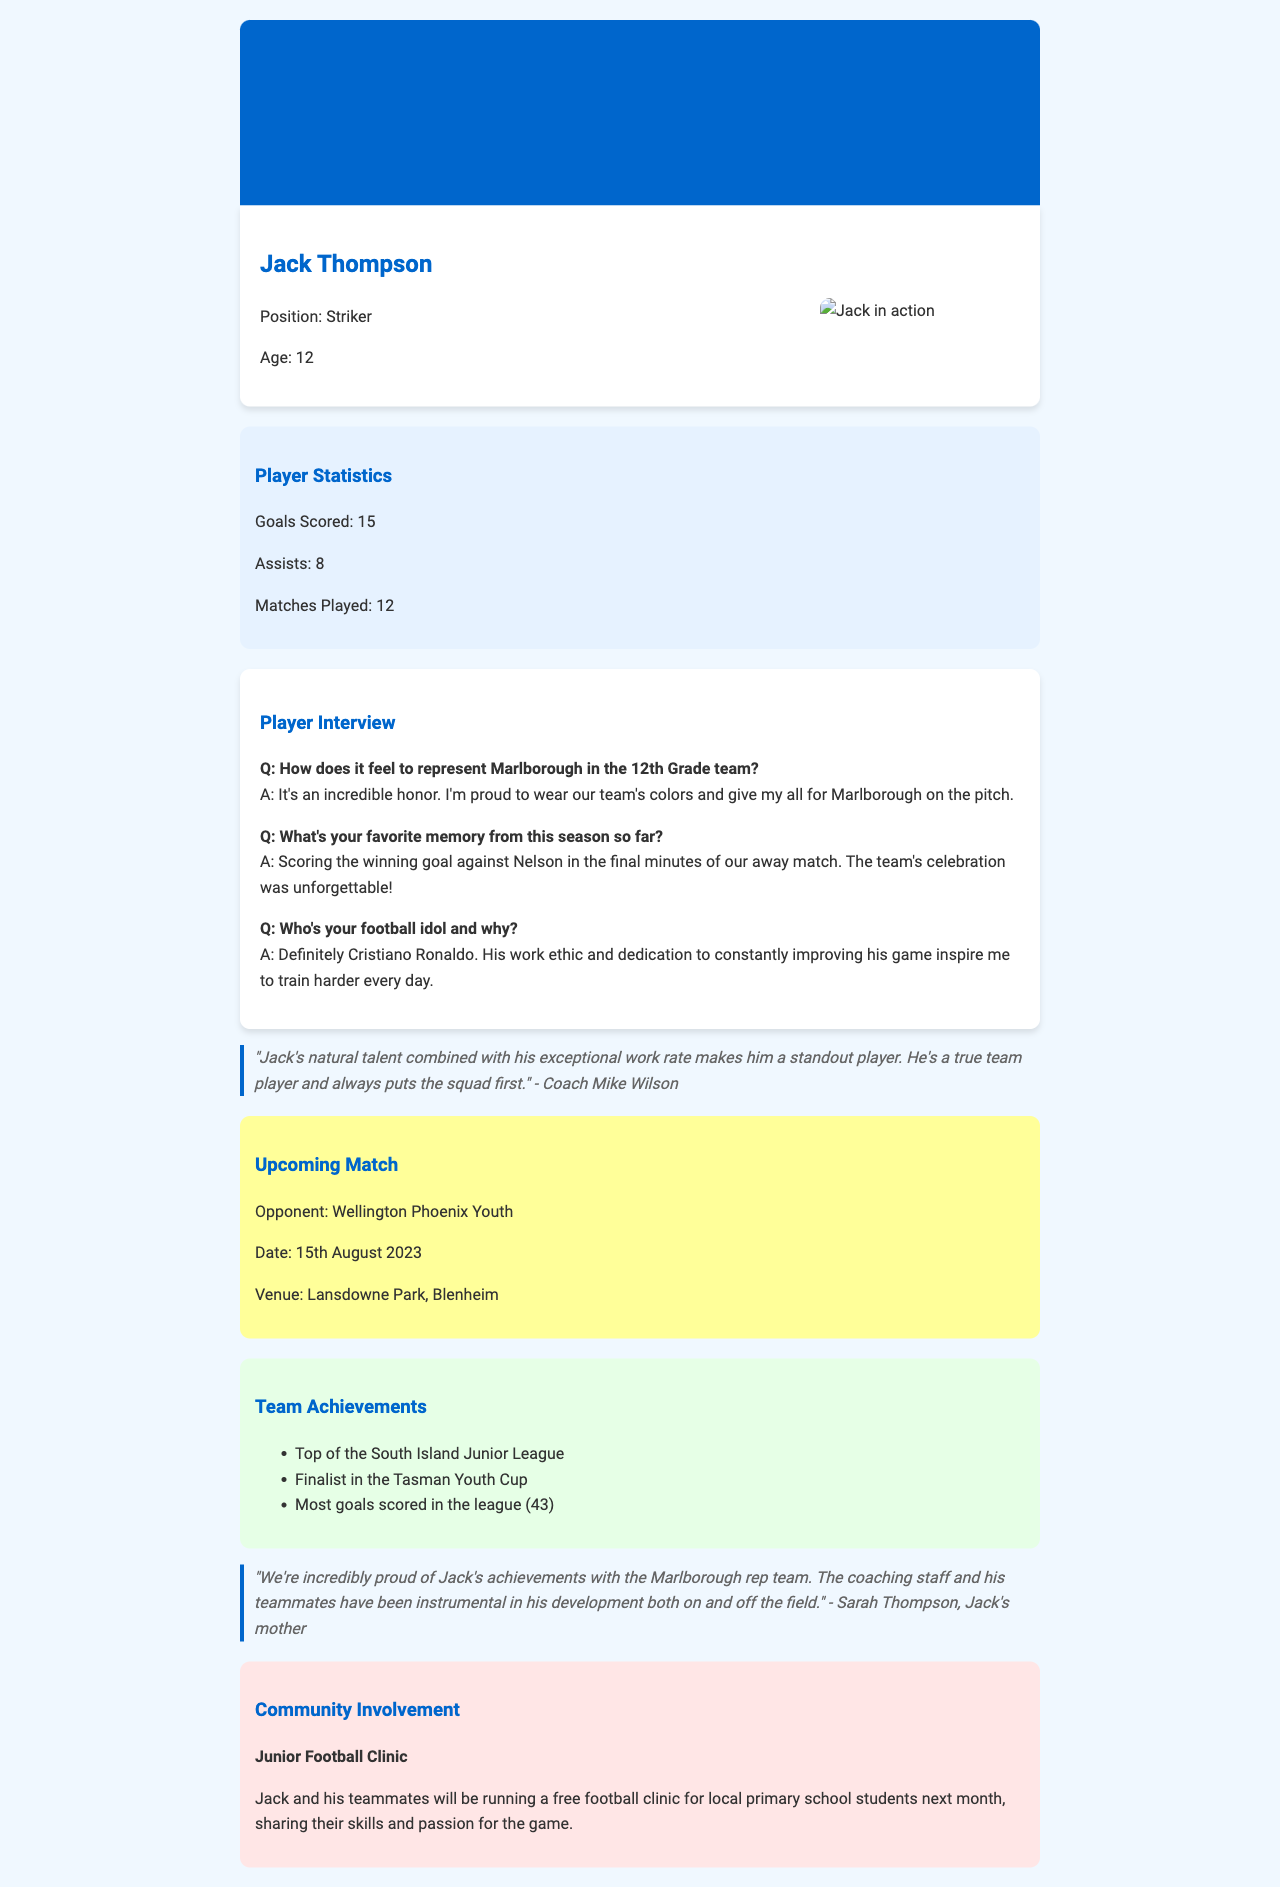What is the name of the featured player? The featured player's name is presented at the beginning of the document.
Answer: Jack Thompson How many goals has Jack scored this season? The number of goals scored by Jack is mentioned in his statistics section.
Answer: 15 Who is the team's upcoming opponent? The upcoming match section specifies the opponent the team will face.
Answer: Wellington Phoenix Youth What is Jack's position on the team? The position of Jack is stated in the player info section of the document.
Answer: Striker How many assists does Jack have this season? The number of assists is included in the player statistics mentioned.
Answer: 8 What was Jack's favorite memory this season? This information is revealed in the interview section where he shares his favorite moment.
Answer: Scoring the winning goal against Nelson What community event will Jack be involved in? The community involvement section describes the event Jack and his teammates are hosting.
Answer: Junior Football Clinic How many matches has Jack played this season? The document clearly lists the total number of matches played by Jack.
Answer: 12 Who commented on Jack's performance as coach? The coach's name and quote regarding Jack's performance can be found in the document.
Answer: Coach Mike Wilson 